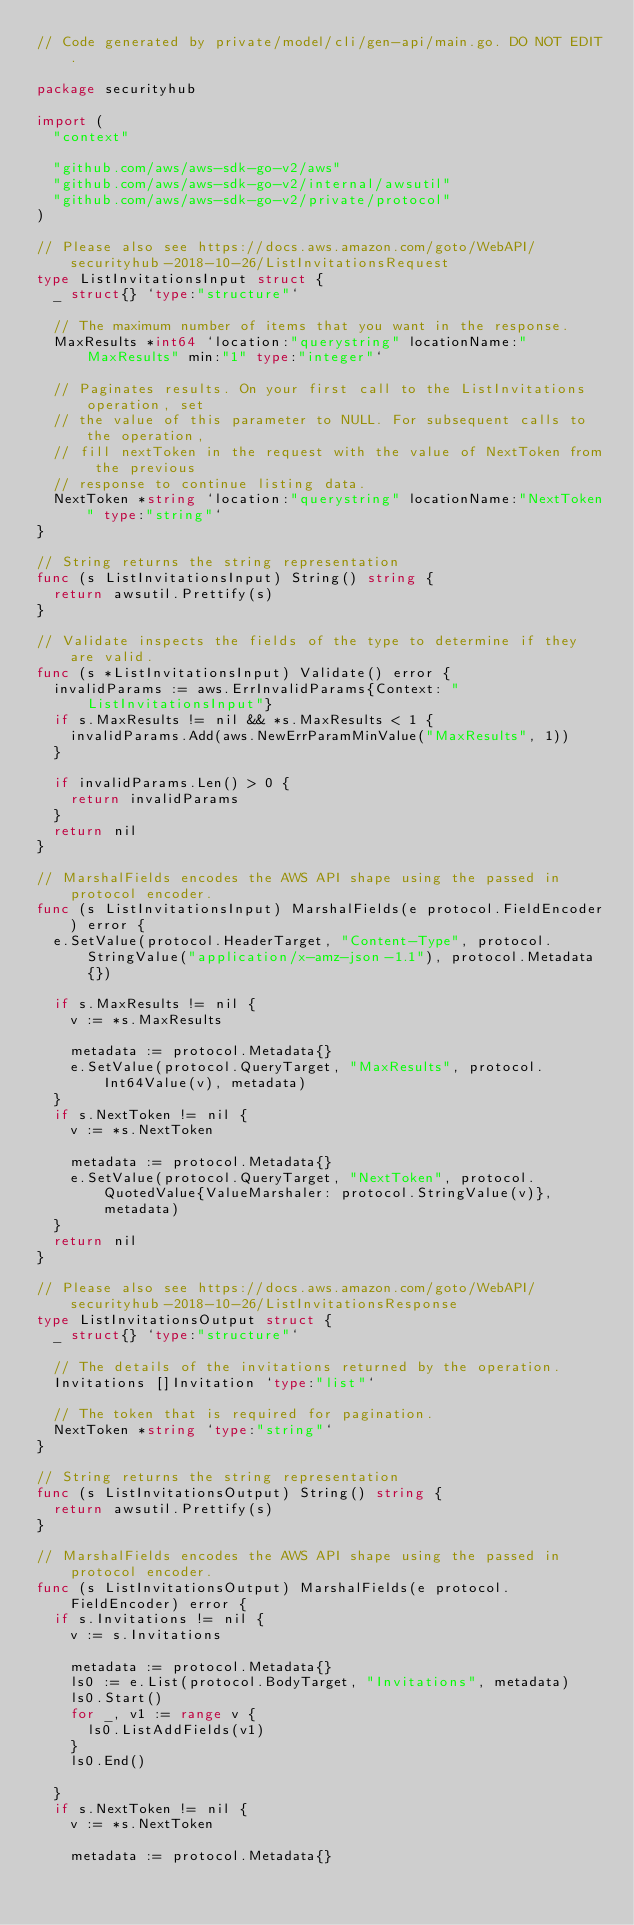Convert code to text. <code><loc_0><loc_0><loc_500><loc_500><_Go_>// Code generated by private/model/cli/gen-api/main.go. DO NOT EDIT.

package securityhub

import (
	"context"

	"github.com/aws/aws-sdk-go-v2/aws"
	"github.com/aws/aws-sdk-go-v2/internal/awsutil"
	"github.com/aws/aws-sdk-go-v2/private/protocol"
)

// Please also see https://docs.aws.amazon.com/goto/WebAPI/securityhub-2018-10-26/ListInvitationsRequest
type ListInvitationsInput struct {
	_ struct{} `type:"structure"`

	// The maximum number of items that you want in the response.
	MaxResults *int64 `location:"querystring" locationName:"MaxResults" min:"1" type:"integer"`

	// Paginates results. On your first call to the ListInvitations operation, set
	// the value of this parameter to NULL. For subsequent calls to the operation,
	// fill nextToken in the request with the value of NextToken from the previous
	// response to continue listing data.
	NextToken *string `location:"querystring" locationName:"NextToken" type:"string"`
}

// String returns the string representation
func (s ListInvitationsInput) String() string {
	return awsutil.Prettify(s)
}

// Validate inspects the fields of the type to determine if they are valid.
func (s *ListInvitationsInput) Validate() error {
	invalidParams := aws.ErrInvalidParams{Context: "ListInvitationsInput"}
	if s.MaxResults != nil && *s.MaxResults < 1 {
		invalidParams.Add(aws.NewErrParamMinValue("MaxResults", 1))
	}

	if invalidParams.Len() > 0 {
		return invalidParams
	}
	return nil
}

// MarshalFields encodes the AWS API shape using the passed in protocol encoder.
func (s ListInvitationsInput) MarshalFields(e protocol.FieldEncoder) error {
	e.SetValue(protocol.HeaderTarget, "Content-Type", protocol.StringValue("application/x-amz-json-1.1"), protocol.Metadata{})

	if s.MaxResults != nil {
		v := *s.MaxResults

		metadata := protocol.Metadata{}
		e.SetValue(protocol.QueryTarget, "MaxResults", protocol.Int64Value(v), metadata)
	}
	if s.NextToken != nil {
		v := *s.NextToken

		metadata := protocol.Metadata{}
		e.SetValue(protocol.QueryTarget, "NextToken", protocol.QuotedValue{ValueMarshaler: protocol.StringValue(v)}, metadata)
	}
	return nil
}

// Please also see https://docs.aws.amazon.com/goto/WebAPI/securityhub-2018-10-26/ListInvitationsResponse
type ListInvitationsOutput struct {
	_ struct{} `type:"structure"`

	// The details of the invitations returned by the operation.
	Invitations []Invitation `type:"list"`

	// The token that is required for pagination.
	NextToken *string `type:"string"`
}

// String returns the string representation
func (s ListInvitationsOutput) String() string {
	return awsutil.Prettify(s)
}

// MarshalFields encodes the AWS API shape using the passed in protocol encoder.
func (s ListInvitationsOutput) MarshalFields(e protocol.FieldEncoder) error {
	if s.Invitations != nil {
		v := s.Invitations

		metadata := protocol.Metadata{}
		ls0 := e.List(protocol.BodyTarget, "Invitations", metadata)
		ls0.Start()
		for _, v1 := range v {
			ls0.ListAddFields(v1)
		}
		ls0.End()

	}
	if s.NextToken != nil {
		v := *s.NextToken

		metadata := protocol.Metadata{}</code> 